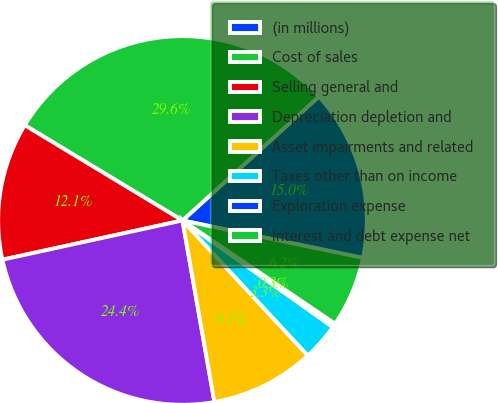<chart> <loc_0><loc_0><loc_500><loc_500><pie_chart><fcel>(in millions)<fcel>Cost of sales<fcel>Selling general and<fcel>Depreciation depletion and<fcel>Asset impairments and related<fcel>Taxes other than on income<fcel>Exploration expense<fcel>Interest and debt expense net<nl><fcel>14.99%<fcel>29.62%<fcel>12.06%<fcel>24.36%<fcel>9.13%<fcel>3.28%<fcel>0.35%<fcel>6.21%<nl></chart> 